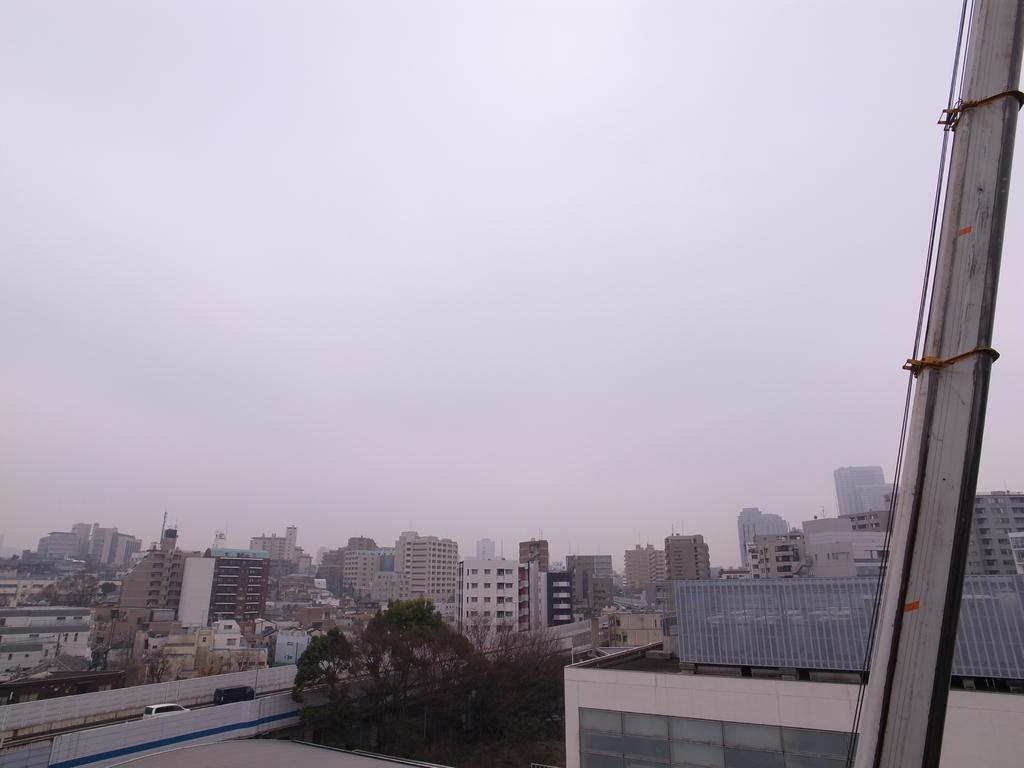In one or two sentences, can you explain what this image depicts? In the image we can see some buildings and trees and vehicles. At the top of the image there are some clouds and sky. 